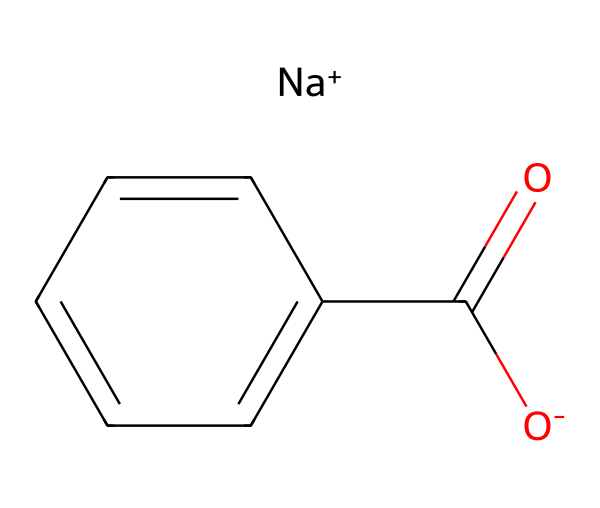What is the molecular formula of sodium benzoate? The molecular formula can be derived by identifying the elements present in the chemical structure. Sodium benzoate contains sodium (Na), carbon (C), hydrogen (H), and oxygen (O). The counts of each element present, from the structure and SMILES representation, lead to the formula C7H5NaO2.
Answer: C7H5NaO2 How many carbon atoms are there in sodium benzoate? By analyzing the SMILES representation, we can see that the main structure has six carbon atoms in the benzene ring, plus one more from the carboxylate group (COO-), leading to a total count of seven carbon atoms.
Answer: 7 What functional group is present in sodium benzoate? The functional group can be identified by examining the carboxylate part of the structure represented in the SMILES (O=C(O-)). This indicates the presence of a carboxylate group, which is characteristic of sodium benzoate.
Answer: carboxylate How many bonds are present in the sodium benzoate structure? By analyzing the structure, we identify single and double bonds. There are six carbon-carbon single bonds (in the benzene ring), one carbon-oxygen double bond (in the carboxylate), and one carbon-oxygen single bond. This gives a total of eight bonds.
Answer: 8 What charge does sodium benzoate carry in solution? The charge can be inferred from the sodium ion (Na+) and the carboxylate ion (O-). The sodium ion carries a positive charge, while the carboxylate has a negative charge, thus the overall charge in solution is neutral.
Answer: neutral What is the role of sodium benzoate in food preservation? Sodium benzoate acts primarily as a preservative, which can be deduced from its usage in food products to inhibit the growth of certain bacteria, yeasts, and fungi, effectively extending shelf life.
Answer: preservative 